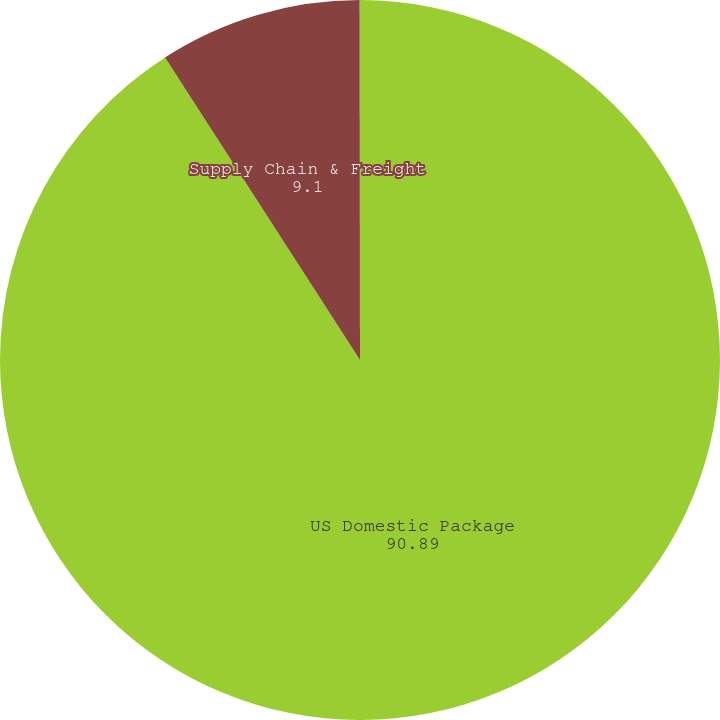<chart> <loc_0><loc_0><loc_500><loc_500><pie_chart><fcel>US Domestic Package<fcel>Supply Chain & Freight<fcel>Diluted<nl><fcel>90.89%<fcel>9.1%<fcel>0.01%<nl></chart> 